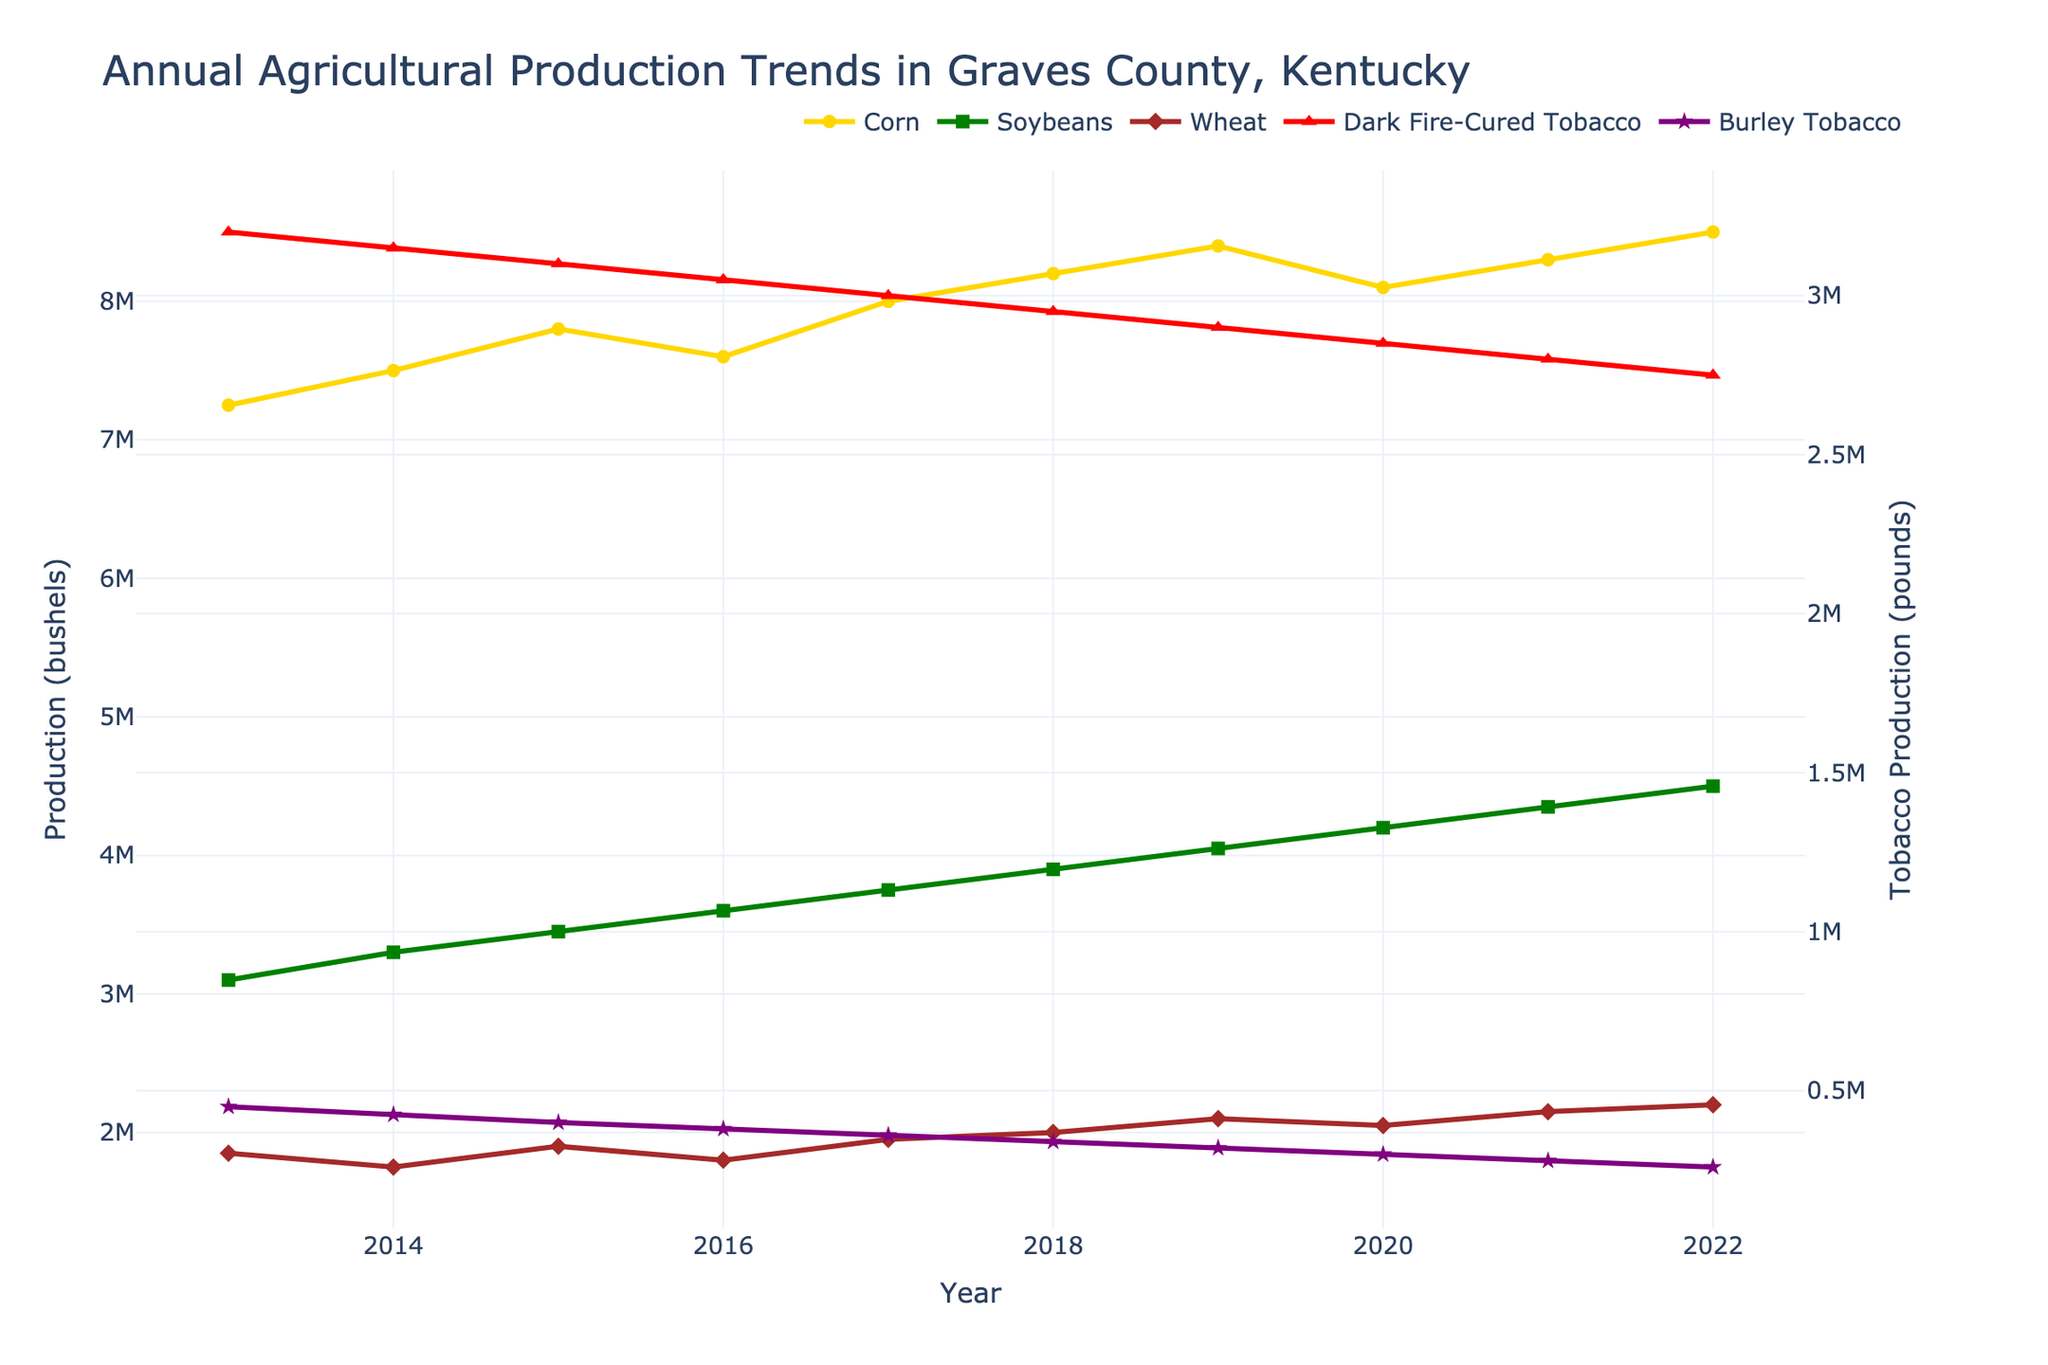What was the overall trend for corn production from 2013 to 2022? Observation of the Corn (bushels) line shows it starting at 7,250,000 bushels in 2013 and ending at 8,500,000 bushels in 2022, indicating a general upward trend.
Answer: Upward trend How did soybean production in 2016 compare to wheat production in the same year? In 2016, soybean production was 3,600,000 bushels, while wheat production was 1,800,000 bushels. Soybean production was therefore significantly higher.
Answer: Soybean production was higher What is the difference in dark fire-cured tobacco production between 2013 and 2022? Dark Fire-Cured Tobacco production was 3,200,000 pounds in 2013 and decreased to 2,750,000 pounds in 2022. The difference is 3,200,000 - 2,750,000 = 450,000 pounds.
Answer: 450,000 pounds Which crop showed the most consistent production levels without drastic fluctuations over the years? By observing the lines, wheat (brown line) appears to have the least variation over the years, maintaining relatively stable production levels.
Answer: Wheat In which year did burley tobacco production show the steepest decline? From 2013 to 2022, the decline seems steepest from 2021 (280,000 pounds) to 2022 (260,000 pounds).
Answer: From 2021 to 2022 Compare the trend of corn production to soybean production. Are their trends similar or different? Both corn and soybean production generally show upward trends, but soybeans increase more steadily each year compared to corn, which shows more variability.
Answer: Similar upward trends but soybeans are more steady By how much did the corn production increase from 2013 to 2019? Corn production in 2019 was 8,400,000 bushels, and in 2013 it was 7,250,000 bushels. The increase is 8,400,000 - 7,250,000 = 1,150,000 bushels.
Answer: 1,150,000 bushels What happened to wheat production between 2017 and 2018? Wheat production increased from 1,950,000 bushels in 2017 to 2,000,000 bushels in 2018.
Answer: Increased Which crop had the highest production level in 2022? In 2022, corn production was the highest among all crops at 8,500,000 bushels.
Answer: Corn How did the production of burley tobacco change over the entire period from 2013 to 2022? Burley Tobacco production showed a consistent decline from 450,000 pounds in 2013 to 260,000 pounds in 2022.
Answer: Consistent decline 